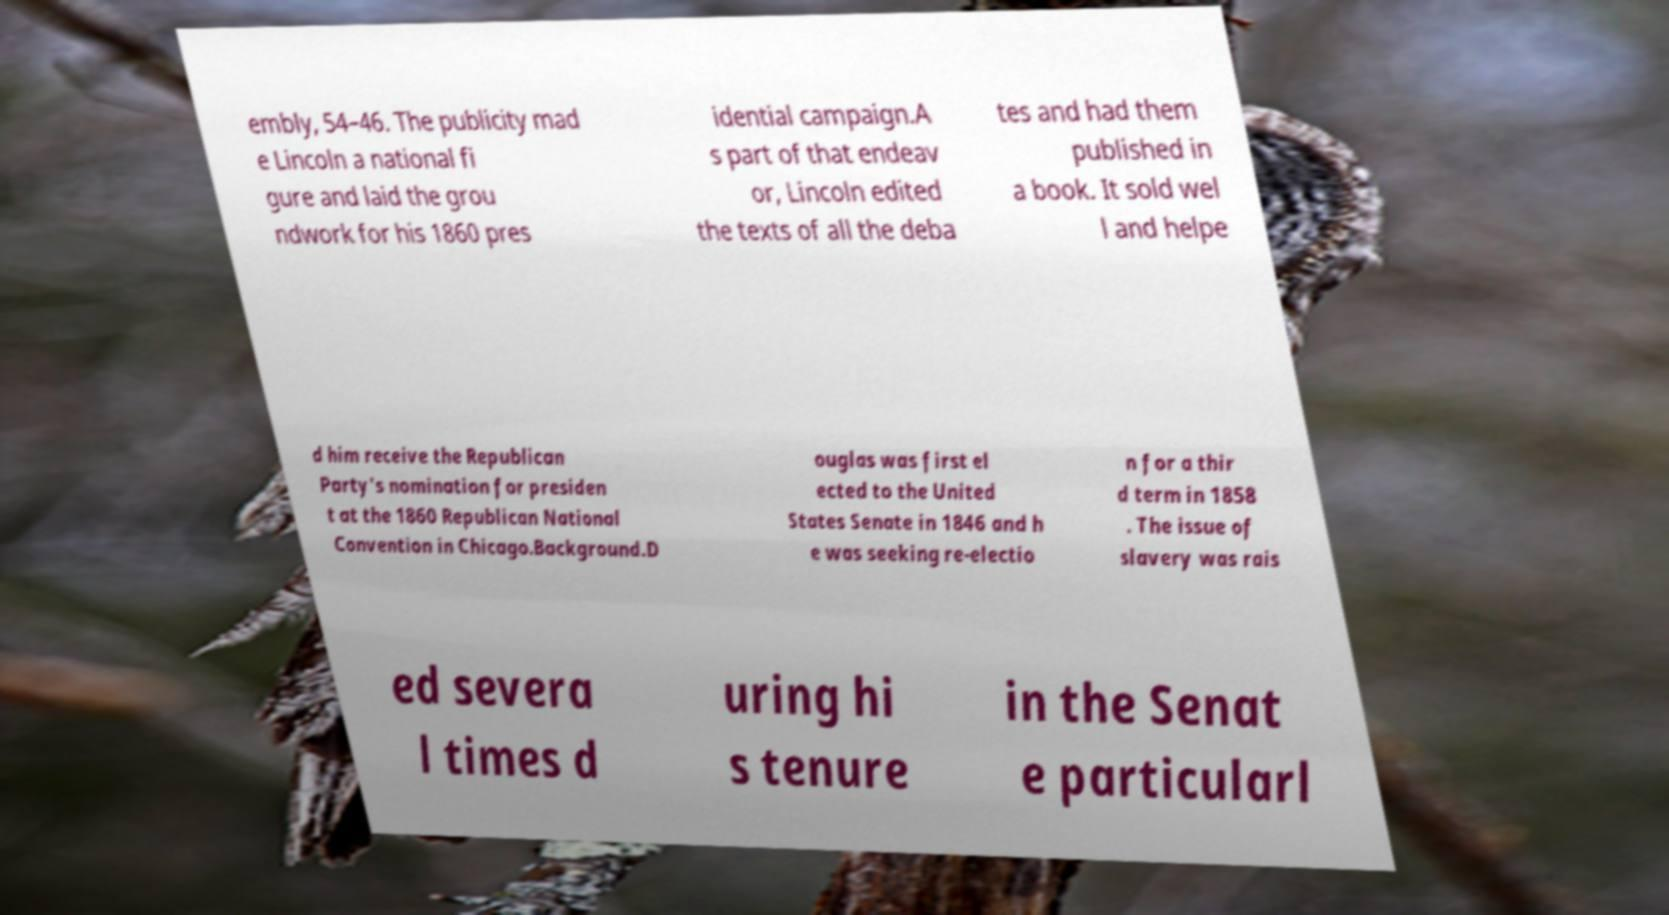There's text embedded in this image that I need extracted. Can you transcribe it verbatim? embly, 54–46. The publicity mad e Lincoln a national fi gure and laid the grou ndwork for his 1860 pres idential campaign.A s part of that endeav or, Lincoln edited the texts of all the deba tes and had them published in a book. It sold wel l and helpe d him receive the Republican Party's nomination for presiden t at the 1860 Republican National Convention in Chicago.Background.D ouglas was first el ected to the United States Senate in 1846 and h e was seeking re-electio n for a thir d term in 1858 . The issue of slavery was rais ed severa l times d uring hi s tenure in the Senat e particularl 